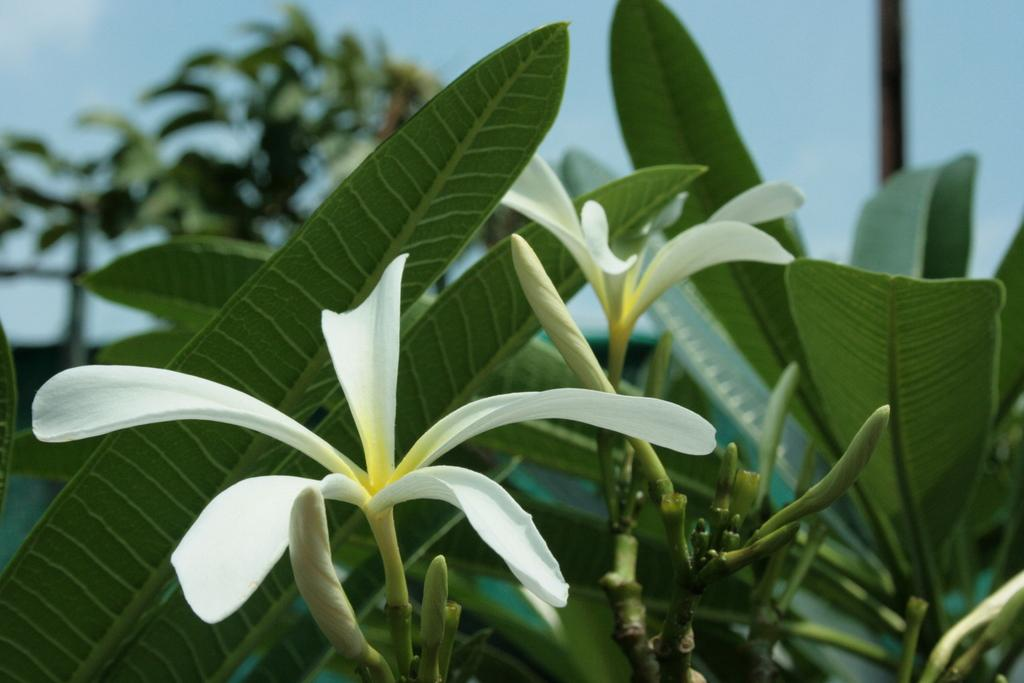What type of flora can be seen in the image? There are flowers in the image. What part of the plant is visible on the stems? There are leaves on the stems of a plant in the image. What can be seen in the background of the image? There are plants visible in the background of the image. What is visible at the top of the image? The sky is visible at the top of the image. How many bikes are parked at the angle shown in the image? There are no bikes present in the image; it features flowers, leaves, and plants. 